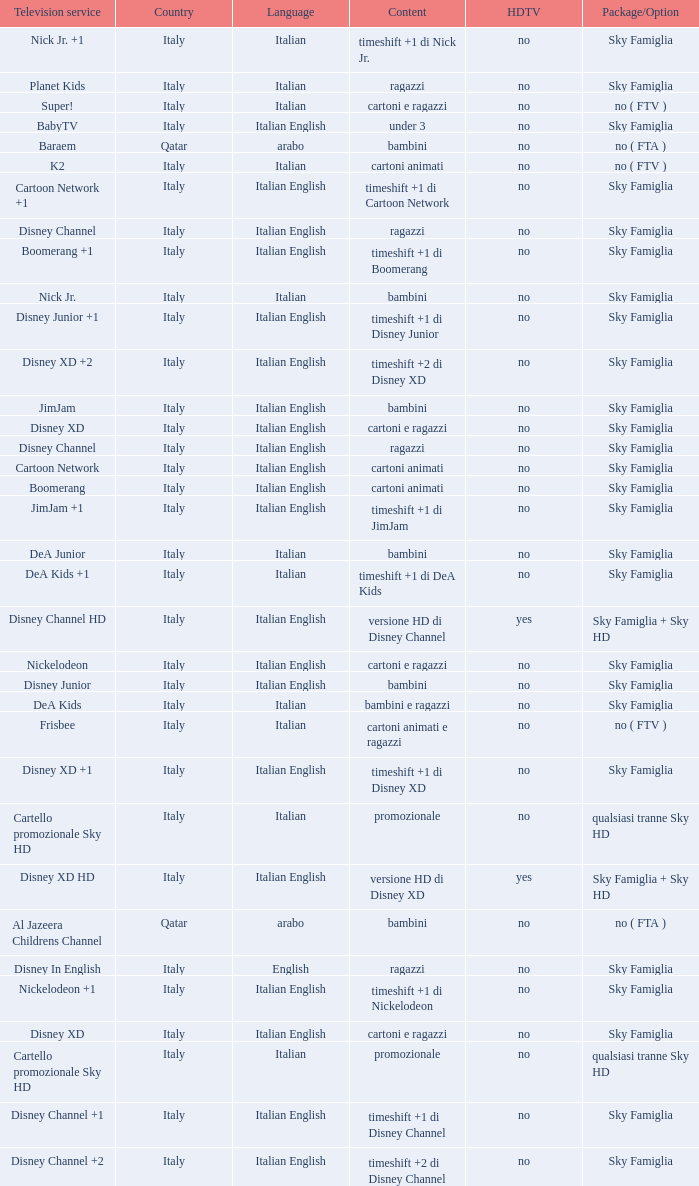What is the Country when the language is italian english, and the television service is disney xd +1? Italy. 